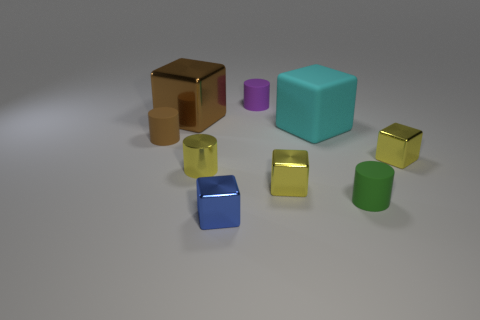Do the large metal cube and the rubber thing left of the blue cube have the same color?
Provide a succinct answer. Yes. What material is the tiny cylinder that is the same color as the large metallic block?
Your response must be concise. Rubber. There is a cyan thing on the right side of the matte cylinder that is behind the tiny matte object that is on the left side of the blue object; how big is it?
Offer a terse response. Large. Are there fewer small purple matte cylinders than metallic objects?
Your answer should be very brief. Yes. There is a large metallic thing that is the same shape as the large cyan rubber object; what color is it?
Make the answer very short. Brown. Are there any metallic blocks behind the small matte cylinder behind the metal object behind the tiny brown object?
Your answer should be compact. No. Does the purple matte object have the same shape as the tiny green object?
Give a very brief answer. Yes. Is the number of small rubber things behind the tiny green thing less than the number of yellow shiny things?
Your answer should be compact. Yes. There is a tiny cylinder to the left of the metal thing behind the block that is on the right side of the small green thing; what color is it?
Provide a succinct answer. Brown. What number of rubber objects are either big purple things or blue objects?
Your response must be concise. 0. 